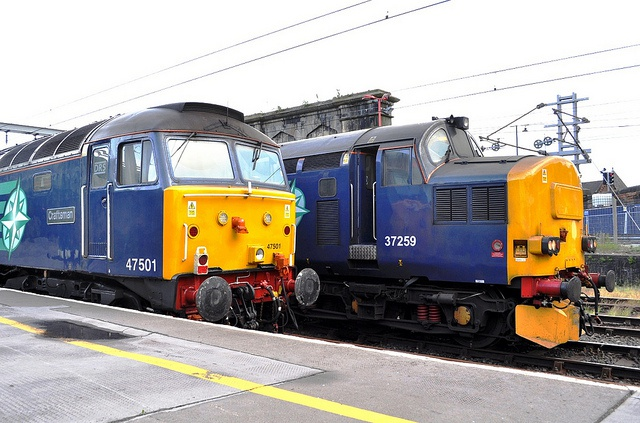Describe the objects in this image and their specific colors. I can see train in white, black, navy, orange, and gray tones, train in white, black, gray, and orange tones, and traffic light in white, black, gray, navy, and darkgray tones in this image. 